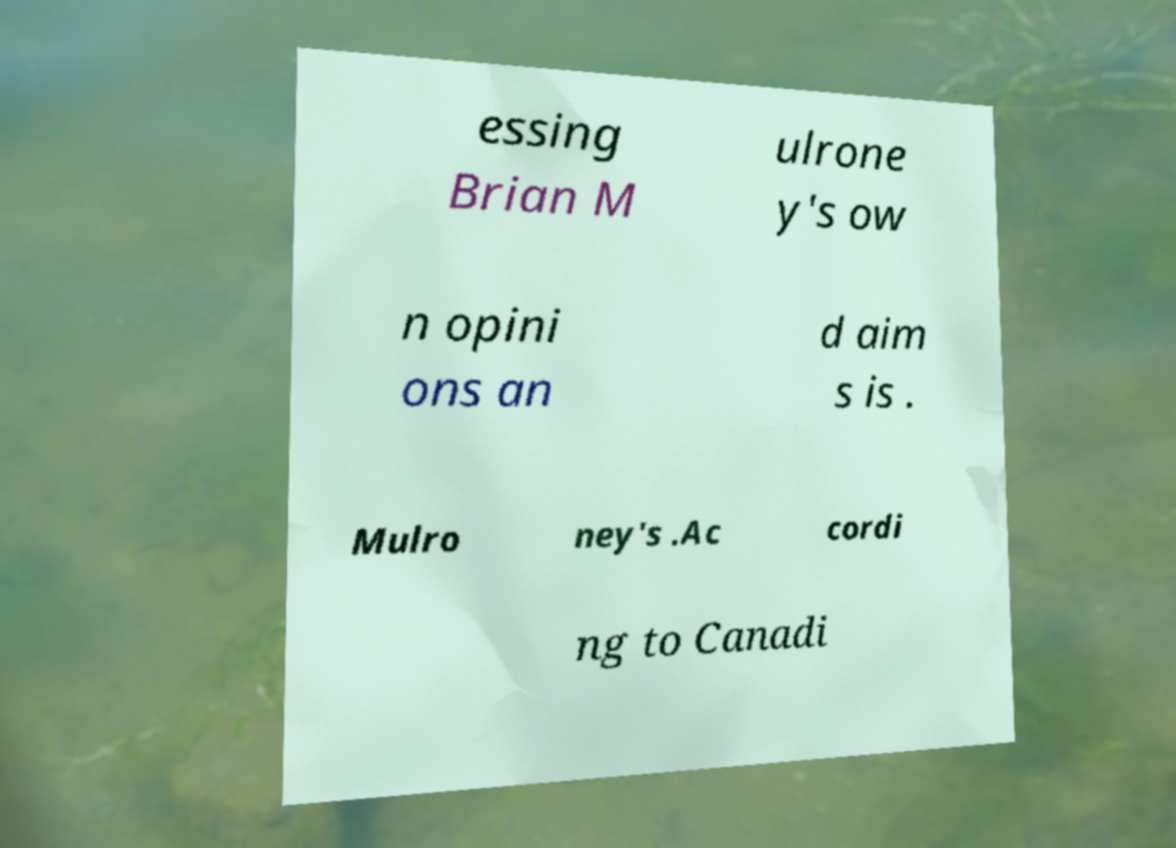Can you read and provide the text displayed in the image?This photo seems to have some interesting text. Can you extract and type it out for me? essing Brian M ulrone y's ow n opini ons an d aim s is . Mulro ney's .Ac cordi ng to Canadi 